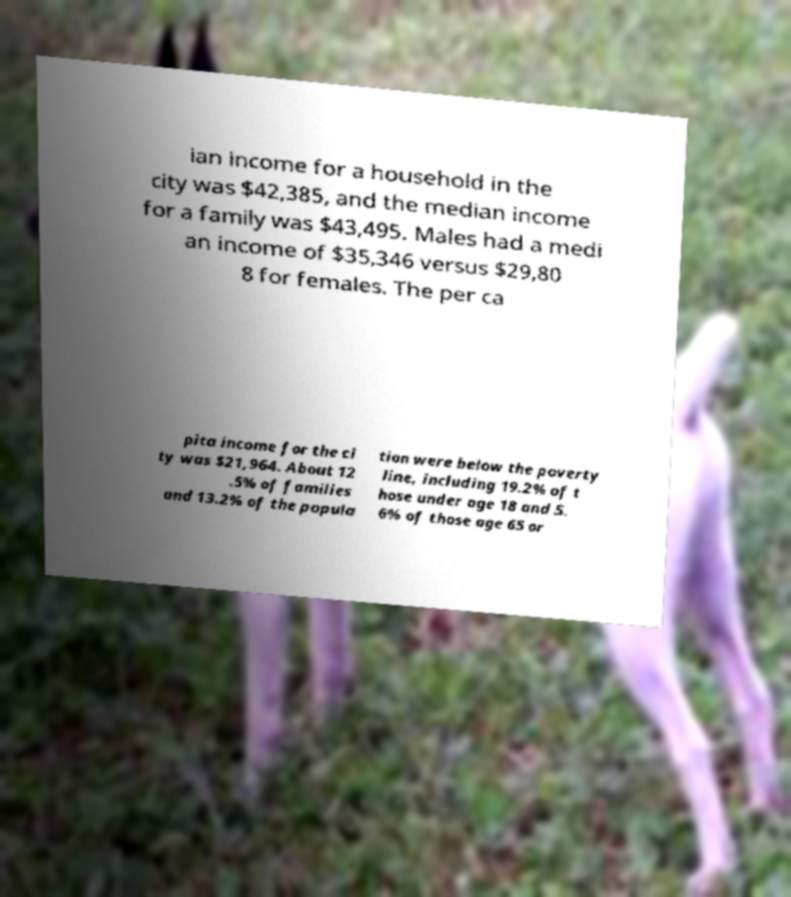There's text embedded in this image that I need extracted. Can you transcribe it verbatim? ian income for a household in the city was $42,385, and the median income for a family was $43,495. Males had a medi an income of $35,346 versus $29,80 8 for females. The per ca pita income for the ci ty was $21,964. About 12 .5% of families and 13.2% of the popula tion were below the poverty line, including 19.2% of t hose under age 18 and 5. 6% of those age 65 or 